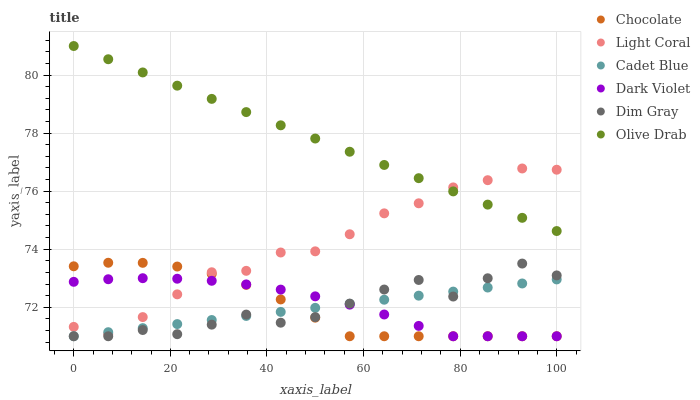Does Cadet Blue have the minimum area under the curve?
Answer yes or no. Yes. Does Olive Drab have the maximum area under the curve?
Answer yes or no. Yes. Does Dark Violet have the minimum area under the curve?
Answer yes or no. No. Does Dark Violet have the maximum area under the curve?
Answer yes or no. No. Is Cadet Blue the smoothest?
Answer yes or no. Yes. Is Dim Gray the roughest?
Answer yes or no. Yes. Is Dark Violet the smoothest?
Answer yes or no. No. Is Dark Violet the roughest?
Answer yes or no. No. Does Dim Gray have the lowest value?
Answer yes or no. Yes. Does Light Coral have the lowest value?
Answer yes or no. No. Does Olive Drab have the highest value?
Answer yes or no. Yes. Does Dark Violet have the highest value?
Answer yes or no. No. Is Chocolate less than Olive Drab?
Answer yes or no. Yes. Is Light Coral greater than Dim Gray?
Answer yes or no. Yes. Does Cadet Blue intersect Dim Gray?
Answer yes or no. Yes. Is Cadet Blue less than Dim Gray?
Answer yes or no. No. Is Cadet Blue greater than Dim Gray?
Answer yes or no. No. Does Chocolate intersect Olive Drab?
Answer yes or no. No. 